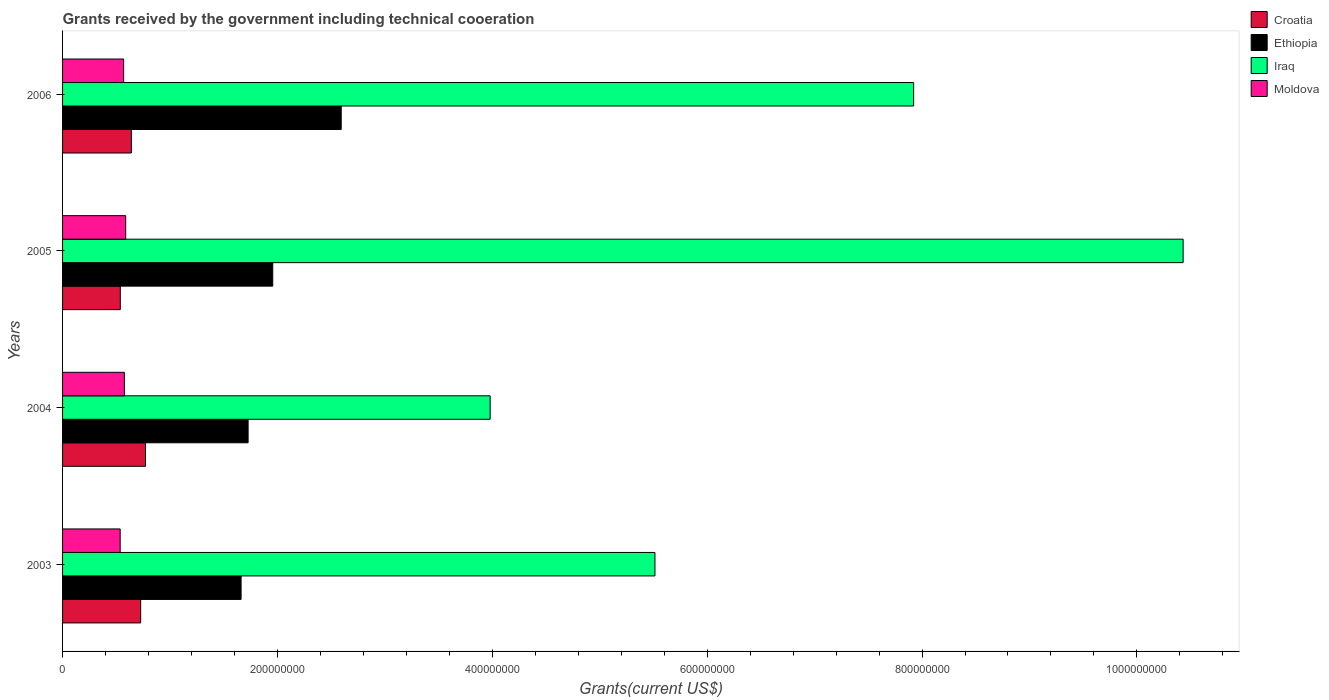How many different coloured bars are there?
Offer a very short reply. 4. In how many cases, is the number of bars for a given year not equal to the number of legend labels?
Give a very brief answer. 0. What is the total grants received by the government in Ethiopia in 2004?
Offer a very short reply. 1.73e+08. Across all years, what is the maximum total grants received by the government in Croatia?
Provide a succinct answer. 7.72e+07. Across all years, what is the minimum total grants received by the government in Iraq?
Your answer should be compact. 3.98e+08. In which year was the total grants received by the government in Croatia maximum?
Provide a succinct answer. 2004. What is the total total grants received by the government in Croatia in the graph?
Provide a succinct answer. 2.68e+08. What is the difference between the total grants received by the government in Croatia in 2003 and that in 2006?
Give a very brief answer. 8.67e+06. What is the difference between the total grants received by the government in Moldova in 2006 and the total grants received by the government in Croatia in 2005?
Give a very brief answer. 3.10e+06. What is the average total grants received by the government in Moldova per year?
Keep it short and to the point. 5.67e+07. In the year 2003, what is the difference between the total grants received by the government in Croatia and total grants received by the government in Moldova?
Ensure brevity in your answer.  1.91e+07. In how many years, is the total grants received by the government in Croatia greater than 160000000 US$?
Your response must be concise. 0. What is the ratio of the total grants received by the government in Croatia in 2003 to that in 2004?
Offer a terse response. 0.94. Is the difference between the total grants received by the government in Croatia in 2003 and 2006 greater than the difference between the total grants received by the government in Moldova in 2003 and 2006?
Your answer should be very brief. Yes. What is the difference between the highest and the second highest total grants received by the government in Moldova?
Give a very brief answer. 1.22e+06. What is the difference between the highest and the lowest total grants received by the government in Moldova?
Your answer should be very brief. 5.13e+06. In how many years, is the total grants received by the government in Iraq greater than the average total grants received by the government in Iraq taken over all years?
Offer a terse response. 2. Is the sum of the total grants received by the government in Croatia in 2004 and 2005 greater than the maximum total grants received by the government in Moldova across all years?
Your answer should be compact. Yes. What does the 4th bar from the top in 2005 represents?
Your response must be concise. Croatia. What does the 4th bar from the bottom in 2003 represents?
Offer a very short reply. Moldova. Is it the case that in every year, the sum of the total grants received by the government in Croatia and total grants received by the government in Ethiopia is greater than the total grants received by the government in Iraq?
Provide a short and direct response. No. Does the graph contain any zero values?
Offer a very short reply. No. Where does the legend appear in the graph?
Offer a very short reply. Top right. How many legend labels are there?
Your response must be concise. 4. What is the title of the graph?
Provide a short and direct response. Grants received by the government including technical cooeration. What is the label or title of the X-axis?
Your answer should be very brief. Grants(current US$). What is the label or title of the Y-axis?
Your answer should be very brief. Years. What is the Grants(current US$) of Croatia in 2003?
Keep it short and to the point. 7.27e+07. What is the Grants(current US$) in Ethiopia in 2003?
Offer a terse response. 1.66e+08. What is the Grants(current US$) of Iraq in 2003?
Keep it short and to the point. 5.51e+08. What is the Grants(current US$) of Moldova in 2003?
Provide a succinct answer. 5.36e+07. What is the Grants(current US$) of Croatia in 2004?
Make the answer very short. 7.72e+07. What is the Grants(current US$) in Ethiopia in 2004?
Keep it short and to the point. 1.73e+08. What is the Grants(current US$) of Iraq in 2004?
Your answer should be compact. 3.98e+08. What is the Grants(current US$) in Moldova in 2004?
Your answer should be compact. 5.75e+07. What is the Grants(current US$) in Croatia in 2005?
Your answer should be very brief. 5.37e+07. What is the Grants(current US$) of Ethiopia in 2005?
Offer a terse response. 1.96e+08. What is the Grants(current US$) of Iraq in 2005?
Keep it short and to the point. 1.04e+09. What is the Grants(current US$) of Moldova in 2005?
Your answer should be very brief. 5.88e+07. What is the Grants(current US$) of Croatia in 2006?
Keep it short and to the point. 6.40e+07. What is the Grants(current US$) of Ethiopia in 2006?
Keep it short and to the point. 2.59e+08. What is the Grants(current US$) of Iraq in 2006?
Keep it short and to the point. 7.92e+08. What is the Grants(current US$) of Moldova in 2006?
Your response must be concise. 5.68e+07. Across all years, what is the maximum Grants(current US$) of Croatia?
Provide a succinct answer. 7.72e+07. Across all years, what is the maximum Grants(current US$) of Ethiopia?
Your response must be concise. 2.59e+08. Across all years, what is the maximum Grants(current US$) in Iraq?
Your response must be concise. 1.04e+09. Across all years, what is the maximum Grants(current US$) of Moldova?
Ensure brevity in your answer.  5.88e+07. Across all years, what is the minimum Grants(current US$) of Croatia?
Keep it short and to the point. 5.37e+07. Across all years, what is the minimum Grants(current US$) of Ethiopia?
Provide a short and direct response. 1.66e+08. Across all years, what is the minimum Grants(current US$) of Iraq?
Offer a terse response. 3.98e+08. Across all years, what is the minimum Grants(current US$) in Moldova?
Give a very brief answer. 5.36e+07. What is the total Grants(current US$) of Croatia in the graph?
Offer a terse response. 2.68e+08. What is the total Grants(current US$) in Ethiopia in the graph?
Offer a terse response. 7.94e+08. What is the total Grants(current US$) of Iraq in the graph?
Offer a terse response. 2.78e+09. What is the total Grants(current US$) of Moldova in the graph?
Offer a terse response. 2.27e+08. What is the difference between the Grants(current US$) of Croatia in 2003 and that in 2004?
Give a very brief answer. -4.50e+06. What is the difference between the Grants(current US$) in Ethiopia in 2003 and that in 2004?
Keep it short and to the point. -6.53e+06. What is the difference between the Grants(current US$) in Iraq in 2003 and that in 2004?
Make the answer very short. 1.53e+08. What is the difference between the Grants(current US$) of Moldova in 2003 and that in 2004?
Offer a terse response. -3.91e+06. What is the difference between the Grants(current US$) in Croatia in 2003 and that in 2005?
Provide a short and direct response. 1.90e+07. What is the difference between the Grants(current US$) of Ethiopia in 2003 and that in 2005?
Keep it short and to the point. -2.95e+07. What is the difference between the Grants(current US$) of Iraq in 2003 and that in 2005?
Offer a very short reply. -4.92e+08. What is the difference between the Grants(current US$) of Moldova in 2003 and that in 2005?
Give a very brief answer. -5.13e+06. What is the difference between the Grants(current US$) in Croatia in 2003 and that in 2006?
Provide a succinct answer. 8.67e+06. What is the difference between the Grants(current US$) in Ethiopia in 2003 and that in 2006?
Keep it short and to the point. -9.32e+07. What is the difference between the Grants(current US$) of Iraq in 2003 and that in 2006?
Ensure brevity in your answer.  -2.41e+08. What is the difference between the Grants(current US$) in Moldova in 2003 and that in 2006?
Provide a succinct answer. -3.22e+06. What is the difference between the Grants(current US$) of Croatia in 2004 and that in 2005?
Make the answer very short. 2.34e+07. What is the difference between the Grants(current US$) of Ethiopia in 2004 and that in 2005?
Give a very brief answer. -2.29e+07. What is the difference between the Grants(current US$) of Iraq in 2004 and that in 2005?
Your response must be concise. -6.45e+08. What is the difference between the Grants(current US$) in Moldova in 2004 and that in 2005?
Your response must be concise. -1.22e+06. What is the difference between the Grants(current US$) in Croatia in 2004 and that in 2006?
Make the answer very short. 1.32e+07. What is the difference between the Grants(current US$) of Ethiopia in 2004 and that in 2006?
Your answer should be very brief. -8.66e+07. What is the difference between the Grants(current US$) in Iraq in 2004 and that in 2006?
Make the answer very short. -3.94e+08. What is the difference between the Grants(current US$) in Moldova in 2004 and that in 2006?
Ensure brevity in your answer.  6.90e+05. What is the difference between the Grants(current US$) of Croatia in 2005 and that in 2006?
Make the answer very short. -1.03e+07. What is the difference between the Grants(current US$) in Ethiopia in 2005 and that in 2006?
Make the answer very short. -6.37e+07. What is the difference between the Grants(current US$) in Iraq in 2005 and that in 2006?
Offer a terse response. 2.51e+08. What is the difference between the Grants(current US$) in Moldova in 2005 and that in 2006?
Your answer should be compact. 1.91e+06. What is the difference between the Grants(current US$) in Croatia in 2003 and the Grants(current US$) in Ethiopia in 2004?
Your response must be concise. -1.00e+08. What is the difference between the Grants(current US$) in Croatia in 2003 and the Grants(current US$) in Iraq in 2004?
Your answer should be very brief. -3.25e+08. What is the difference between the Grants(current US$) of Croatia in 2003 and the Grants(current US$) of Moldova in 2004?
Provide a short and direct response. 1.52e+07. What is the difference between the Grants(current US$) in Ethiopia in 2003 and the Grants(current US$) in Iraq in 2004?
Your answer should be compact. -2.32e+08. What is the difference between the Grants(current US$) in Ethiopia in 2003 and the Grants(current US$) in Moldova in 2004?
Keep it short and to the point. 1.09e+08. What is the difference between the Grants(current US$) in Iraq in 2003 and the Grants(current US$) in Moldova in 2004?
Keep it short and to the point. 4.94e+08. What is the difference between the Grants(current US$) in Croatia in 2003 and the Grants(current US$) in Ethiopia in 2005?
Provide a short and direct response. -1.23e+08. What is the difference between the Grants(current US$) of Croatia in 2003 and the Grants(current US$) of Iraq in 2005?
Keep it short and to the point. -9.70e+08. What is the difference between the Grants(current US$) in Croatia in 2003 and the Grants(current US$) in Moldova in 2005?
Keep it short and to the point. 1.39e+07. What is the difference between the Grants(current US$) of Ethiopia in 2003 and the Grants(current US$) of Iraq in 2005?
Give a very brief answer. -8.77e+08. What is the difference between the Grants(current US$) in Ethiopia in 2003 and the Grants(current US$) in Moldova in 2005?
Ensure brevity in your answer.  1.07e+08. What is the difference between the Grants(current US$) of Iraq in 2003 and the Grants(current US$) of Moldova in 2005?
Ensure brevity in your answer.  4.93e+08. What is the difference between the Grants(current US$) of Croatia in 2003 and the Grants(current US$) of Ethiopia in 2006?
Make the answer very short. -1.87e+08. What is the difference between the Grants(current US$) of Croatia in 2003 and the Grants(current US$) of Iraq in 2006?
Keep it short and to the point. -7.20e+08. What is the difference between the Grants(current US$) in Croatia in 2003 and the Grants(current US$) in Moldova in 2006?
Ensure brevity in your answer.  1.58e+07. What is the difference between the Grants(current US$) of Ethiopia in 2003 and the Grants(current US$) of Iraq in 2006?
Keep it short and to the point. -6.26e+08. What is the difference between the Grants(current US$) in Ethiopia in 2003 and the Grants(current US$) in Moldova in 2006?
Your response must be concise. 1.09e+08. What is the difference between the Grants(current US$) of Iraq in 2003 and the Grants(current US$) of Moldova in 2006?
Give a very brief answer. 4.95e+08. What is the difference between the Grants(current US$) of Croatia in 2004 and the Grants(current US$) of Ethiopia in 2005?
Offer a very short reply. -1.18e+08. What is the difference between the Grants(current US$) in Croatia in 2004 and the Grants(current US$) in Iraq in 2005?
Give a very brief answer. -9.66e+08. What is the difference between the Grants(current US$) of Croatia in 2004 and the Grants(current US$) of Moldova in 2005?
Give a very brief answer. 1.84e+07. What is the difference between the Grants(current US$) in Ethiopia in 2004 and the Grants(current US$) in Iraq in 2005?
Give a very brief answer. -8.70e+08. What is the difference between the Grants(current US$) of Ethiopia in 2004 and the Grants(current US$) of Moldova in 2005?
Your answer should be compact. 1.14e+08. What is the difference between the Grants(current US$) of Iraq in 2004 and the Grants(current US$) of Moldova in 2005?
Keep it short and to the point. 3.39e+08. What is the difference between the Grants(current US$) in Croatia in 2004 and the Grants(current US$) in Ethiopia in 2006?
Keep it short and to the point. -1.82e+08. What is the difference between the Grants(current US$) in Croatia in 2004 and the Grants(current US$) in Iraq in 2006?
Offer a terse response. -7.15e+08. What is the difference between the Grants(current US$) in Croatia in 2004 and the Grants(current US$) in Moldova in 2006?
Your response must be concise. 2.04e+07. What is the difference between the Grants(current US$) of Ethiopia in 2004 and the Grants(current US$) of Iraq in 2006?
Offer a very short reply. -6.19e+08. What is the difference between the Grants(current US$) of Ethiopia in 2004 and the Grants(current US$) of Moldova in 2006?
Provide a short and direct response. 1.16e+08. What is the difference between the Grants(current US$) in Iraq in 2004 and the Grants(current US$) in Moldova in 2006?
Your answer should be compact. 3.41e+08. What is the difference between the Grants(current US$) of Croatia in 2005 and the Grants(current US$) of Ethiopia in 2006?
Provide a succinct answer. -2.06e+08. What is the difference between the Grants(current US$) in Croatia in 2005 and the Grants(current US$) in Iraq in 2006?
Ensure brevity in your answer.  -7.38e+08. What is the difference between the Grants(current US$) in Croatia in 2005 and the Grants(current US$) in Moldova in 2006?
Offer a very short reply. -3.10e+06. What is the difference between the Grants(current US$) of Ethiopia in 2005 and the Grants(current US$) of Iraq in 2006?
Make the answer very short. -5.97e+08. What is the difference between the Grants(current US$) in Ethiopia in 2005 and the Grants(current US$) in Moldova in 2006?
Make the answer very short. 1.39e+08. What is the difference between the Grants(current US$) in Iraq in 2005 and the Grants(current US$) in Moldova in 2006?
Your answer should be very brief. 9.86e+08. What is the average Grants(current US$) of Croatia per year?
Offer a very short reply. 6.69e+07. What is the average Grants(current US$) in Ethiopia per year?
Your answer should be compact. 1.98e+08. What is the average Grants(current US$) of Iraq per year?
Ensure brevity in your answer.  6.96e+08. What is the average Grants(current US$) of Moldova per year?
Keep it short and to the point. 5.67e+07. In the year 2003, what is the difference between the Grants(current US$) in Croatia and Grants(current US$) in Ethiopia?
Your answer should be compact. -9.35e+07. In the year 2003, what is the difference between the Grants(current US$) of Croatia and Grants(current US$) of Iraq?
Ensure brevity in your answer.  -4.79e+08. In the year 2003, what is the difference between the Grants(current US$) in Croatia and Grants(current US$) in Moldova?
Provide a succinct answer. 1.91e+07. In the year 2003, what is the difference between the Grants(current US$) of Ethiopia and Grants(current US$) of Iraq?
Provide a succinct answer. -3.85e+08. In the year 2003, what is the difference between the Grants(current US$) in Ethiopia and Grants(current US$) in Moldova?
Give a very brief answer. 1.13e+08. In the year 2003, what is the difference between the Grants(current US$) in Iraq and Grants(current US$) in Moldova?
Your answer should be compact. 4.98e+08. In the year 2004, what is the difference between the Grants(current US$) in Croatia and Grants(current US$) in Ethiopia?
Your answer should be compact. -9.55e+07. In the year 2004, what is the difference between the Grants(current US$) of Croatia and Grants(current US$) of Iraq?
Make the answer very short. -3.21e+08. In the year 2004, what is the difference between the Grants(current US$) of Croatia and Grants(current US$) of Moldova?
Make the answer very short. 1.97e+07. In the year 2004, what is the difference between the Grants(current US$) in Ethiopia and Grants(current US$) in Iraq?
Your answer should be very brief. -2.25e+08. In the year 2004, what is the difference between the Grants(current US$) of Ethiopia and Grants(current US$) of Moldova?
Your response must be concise. 1.15e+08. In the year 2004, what is the difference between the Grants(current US$) of Iraq and Grants(current US$) of Moldova?
Offer a very short reply. 3.40e+08. In the year 2005, what is the difference between the Grants(current US$) in Croatia and Grants(current US$) in Ethiopia?
Your answer should be compact. -1.42e+08. In the year 2005, what is the difference between the Grants(current US$) in Croatia and Grants(current US$) in Iraq?
Make the answer very short. -9.89e+08. In the year 2005, what is the difference between the Grants(current US$) in Croatia and Grants(current US$) in Moldova?
Offer a very short reply. -5.01e+06. In the year 2005, what is the difference between the Grants(current US$) in Ethiopia and Grants(current US$) in Iraq?
Your answer should be compact. -8.47e+08. In the year 2005, what is the difference between the Grants(current US$) in Ethiopia and Grants(current US$) in Moldova?
Your answer should be compact. 1.37e+08. In the year 2005, what is the difference between the Grants(current US$) in Iraq and Grants(current US$) in Moldova?
Your answer should be very brief. 9.84e+08. In the year 2006, what is the difference between the Grants(current US$) in Croatia and Grants(current US$) in Ethiopia?
Keep it short and to the point. -1.95e+08. In the year 2006, what is the difference between the Grants(current US$) of Croatia and Grants(current US$) of Iraq?
Give a very brief answer. -7.28e+08. In the year 2006, what is the difference between the Grants(current US$) of Croatia and Grants(current US$) of Moldova?
Your answer should be very brief. 7.18e+06. In the year 2006, what is the difference between the Grants(current US$) of Ethiopia and Grants(current US$) of Iraq?
Ensure brevity in your answer.  -5.33e+08. In the year 2006, what is the difference between the Grants(current US$) of Ethiopia and Grants(current US$) of Moldova?
Make the answer very short. 2.03e+08. In the year 2006, what is the difference between the Grants(current US$) in Iraq and Grants(current US$) in Moldova?
Ensure brevity in your answer.  7.35e+08. What is the ratio of the Grants(current US$) of Croatia in 2003 to that in 2004?
Ensure brevity in your answer.  0.94. What is the ratio of the Grants(current US$) in Ethiopia in 2003 to that in 2004?
Offer a terse response. 0.96. What is the ratio of the Grants(current US$) in Iraq in 2003 to that in 2004?
Offer a terse response. 1.39. What is the ratio of the Grants(current US$) in Moldova in 2003 to that in 2004?
Your answer should be compact. 0.93. What is the ratio of the Grants(current US$) in Croatia in 2003 to that in 2005?
Your response must be concise. 1.35. What is the ratio of the Grants(current US$) of Ethiopia in 2003 to that in 2005?
Provide a short and direct response. 0.85. What is the ratio of the Grants(current US$) of Iraq in 2003 to that in 2005?
Your answer should be very brief. 0.53. What is the ratio of the Grants(current US$) of Moldova in 2003 to that in 2005?
Your response must be concise. 0.91. What is the ratio of the Grants(current US$) in Croatia in 2003 to that in 2006?
Make the answer very short. 1.14. What is the ratio of the Grants(current US$) in Ethiopia in 2003 to that in 2006?
Ensure brevity in your answer.  0.64. What is the ratio of the Grants(current US$) of Iraq in 2003 to that in 2006?
Give a very brief answer. 0.7. What is the ratio of the Grants(current US$) of Moldova in 2003 to that in 2006?
Provide a succinct answer. 0.94. What is the ratio of the Grants(current US$) of Croatia in 2004 to that in 2005?
Make the answer very short. 1.44. What is the ratio of the Grants(current US$) in Ethiopia in 2004 to that in 2005?
Make the answer very short. 0.88. What is the ratio of the Grants(current US$) in Iraq in 2004 to that in 2005?
Offer a very short reply. 0.38. What is the ratio of the Grants(current US$) of Moldova in 2004 to that in 2005?
Provide a succinct answer. 0.98. What is the ratio of the Grants(current US$) of Croatia in 2004 to that in 2006?
Your response must be concise. 1.21. What is the ratio of the Grants(current US$) of Ethiopia in 2004 to that in 2006?
Give a very brief answer. 0.67. What is the ratio of the Grants(current US$) in Iraq in 2004 to that in 2006?
Provide a short and direct response. 0.5. What is the ratio of the Grants(current US$) of Moldova in 2004 to that in 2006?
Provide a succinct answer. 1.01. What is the ratio of the Grants(current US$) in Croatia in 2005 to that in 2006?
Your answer should be very brief. 0.84. What is the ratio of the Grants(current US$) in Ethiopia in 2005 to that in 2006?
Provide a succinct answer. 0.75. What is the ratio of the Grants(current US$) of Iraq in 2005 to that in 2006?
Make the answer very short. 1.32. What is the ratio of the Grants(current US$) of Moldova in 2005 to that in 2006?
Keep it short and to the point. 1.03. What is the difference between the highest and the second highest Grants(current US$) in Croatia?
Offer a terse response. 4.50e+06. What is the difference between the highest and the second highest Grants(current US$) in Ethiopia?
Offer a very short reply. 6.37e+07. What is the difference between the highest and the second highest Grants(current US$) of Iraq?
Provide a short and direct response. 2.51e+08. What is the difference between the highest and the second highest Grants(current US$) in Moldova?
Provide a short and direct response. 1.22e+06. What is the difference between the highest and the lowest Grants(current US$) in Croatia?
Your response must be concise. 2.34e+07. What is the difference between the highest and the lowest Grants(current US$) of Ethiopia?
Give a very brief answer. 9.32e+07. What is the difference between the highest and the lowest Grants(current US$) in Iraq?
Give a very brief answer. 6.45e+08. What is the difference between the highest and the lowest Grants(current US$) of Moldova?
Your answer should be compact. 5.13e+06. 